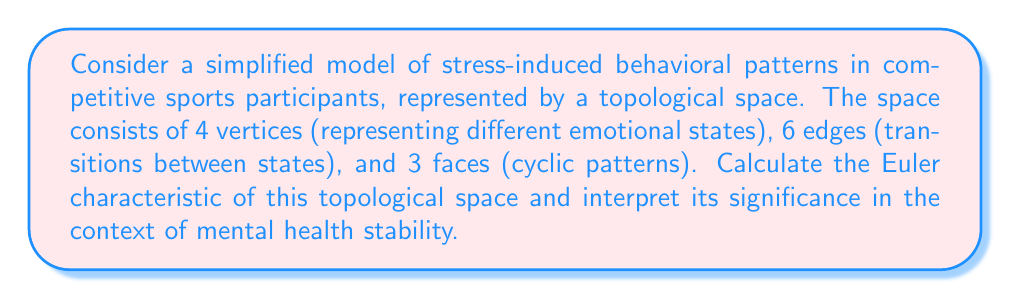Show me your answer to this math problem. To solve this problem, we'll use the Euler characteristic formula and interpret the result in the context of mental health stability for competitive sports participants.

1. Recall the Euler characteristic formula:
   $$\chi = V - E + F$$
   Where:
   $\chi$ = Euler characteristic
   $V$ = number of vertices
   $E$ = number of edges
   $F$ = number of faces

2. Given information:
   $V = 4$ (emotional states)
   $E = 6$ (transitions between states)
   $F = 3$ (cyclic patterns)

3. Substituting these values into the formula:
   $$\chi = 4 - 6 + 3 = 1$$

4. Interpretation:
   The Euler characteristic of 1 suggests a topologically simple structure, equivalent to a sphere or a disk. In the context of mental health stability:

   a) Positive $\chi$: Indicates a certain level of resilience or stability in the overall emotional system.
   b) $\chi = 1$: Suggests a balanced, but potentially vulnerable system.
   c) Low complexity: The small number of vertices, edges, and faces implies a simplified model that may not capture the full complexity of real-world emotional states.

   This result could be interpreted as showing that while there is some inherent stability in the emotional patterns of competitive sports participants, the system is not overly complex and may be susceptible to significant changes or stressors.
Answer: The Euler characteristic of the given stress-induced behavioral pattern model is $\chi = 1$, indicating a topologically simple structure with some inherent stability but potential vulnerability to significant stressors in competitive sports participants' mental health. 